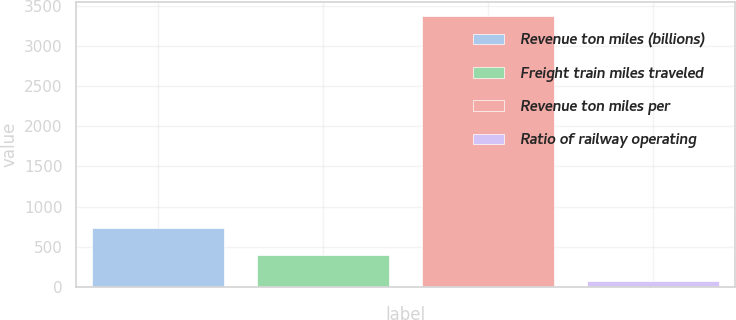Convert chart to OTSL. <chart><loc_0><loc_0><loc_500><loc_500><bar_chart><fcel>Revenue ton miles (billions)<fcel>Freight train miles traveled<fcel>Revenue ton miles per<fcel>Ratio of railway operating<nl><fcel>732<fcel>401.5<fcel>3376<fcel>71<nl></chart> 